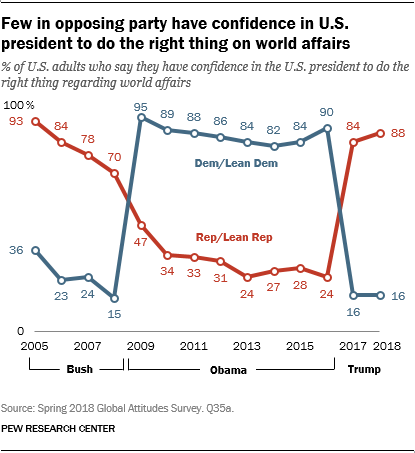Specify some key components in this picture. The average of the highest value in the blue graph and the rightmost value in the red graph is approximately 91.5. The rightmost value of the red bar is 88. 